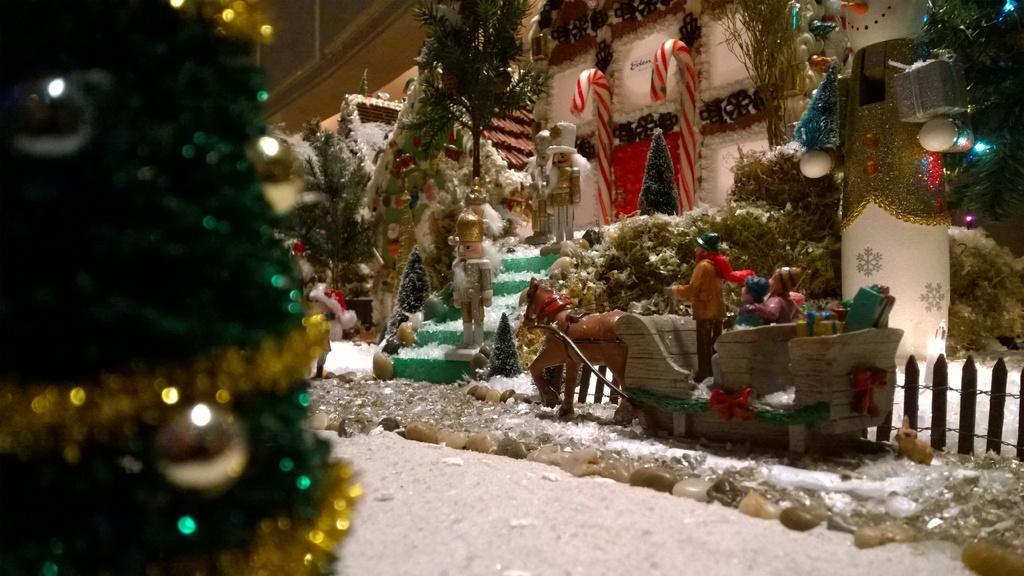Describe this image in one or two sentences. In this image we can see a group of toys. We can also see some trees decorated and decors. In the foreground we can see some stones. 